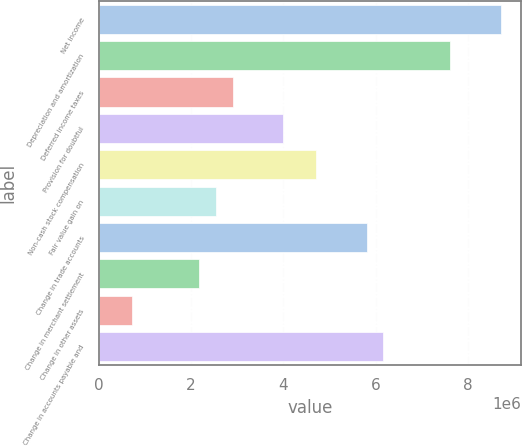Convert chart. <chart><loc_0><loc_0><loc_500><loc_500><bar_chart><fcel>Net income<fcel>Depreciation and amortization<fcel>Deferred income taxes<fcel>Provision for doubtful<fcel>Non-cash stock compensation<fcel>Fair value gain on<fcel>Change in trade accounts<fcel>Change in merchant settlement<fcel>Change in other assets<fcel>Change in accounts payable and<nl><fcel>8.71113e+06<fcel>7.62229e+06<fcel>2.90397e+06<fcel>3.99282e+06<fcel>4.71871e+06<fcel>2.54103e+06<fcel>5.80755e+06<fcel>2.17808e+06<fcel>726291<fcel>6.1705e+06<nl></chart> 